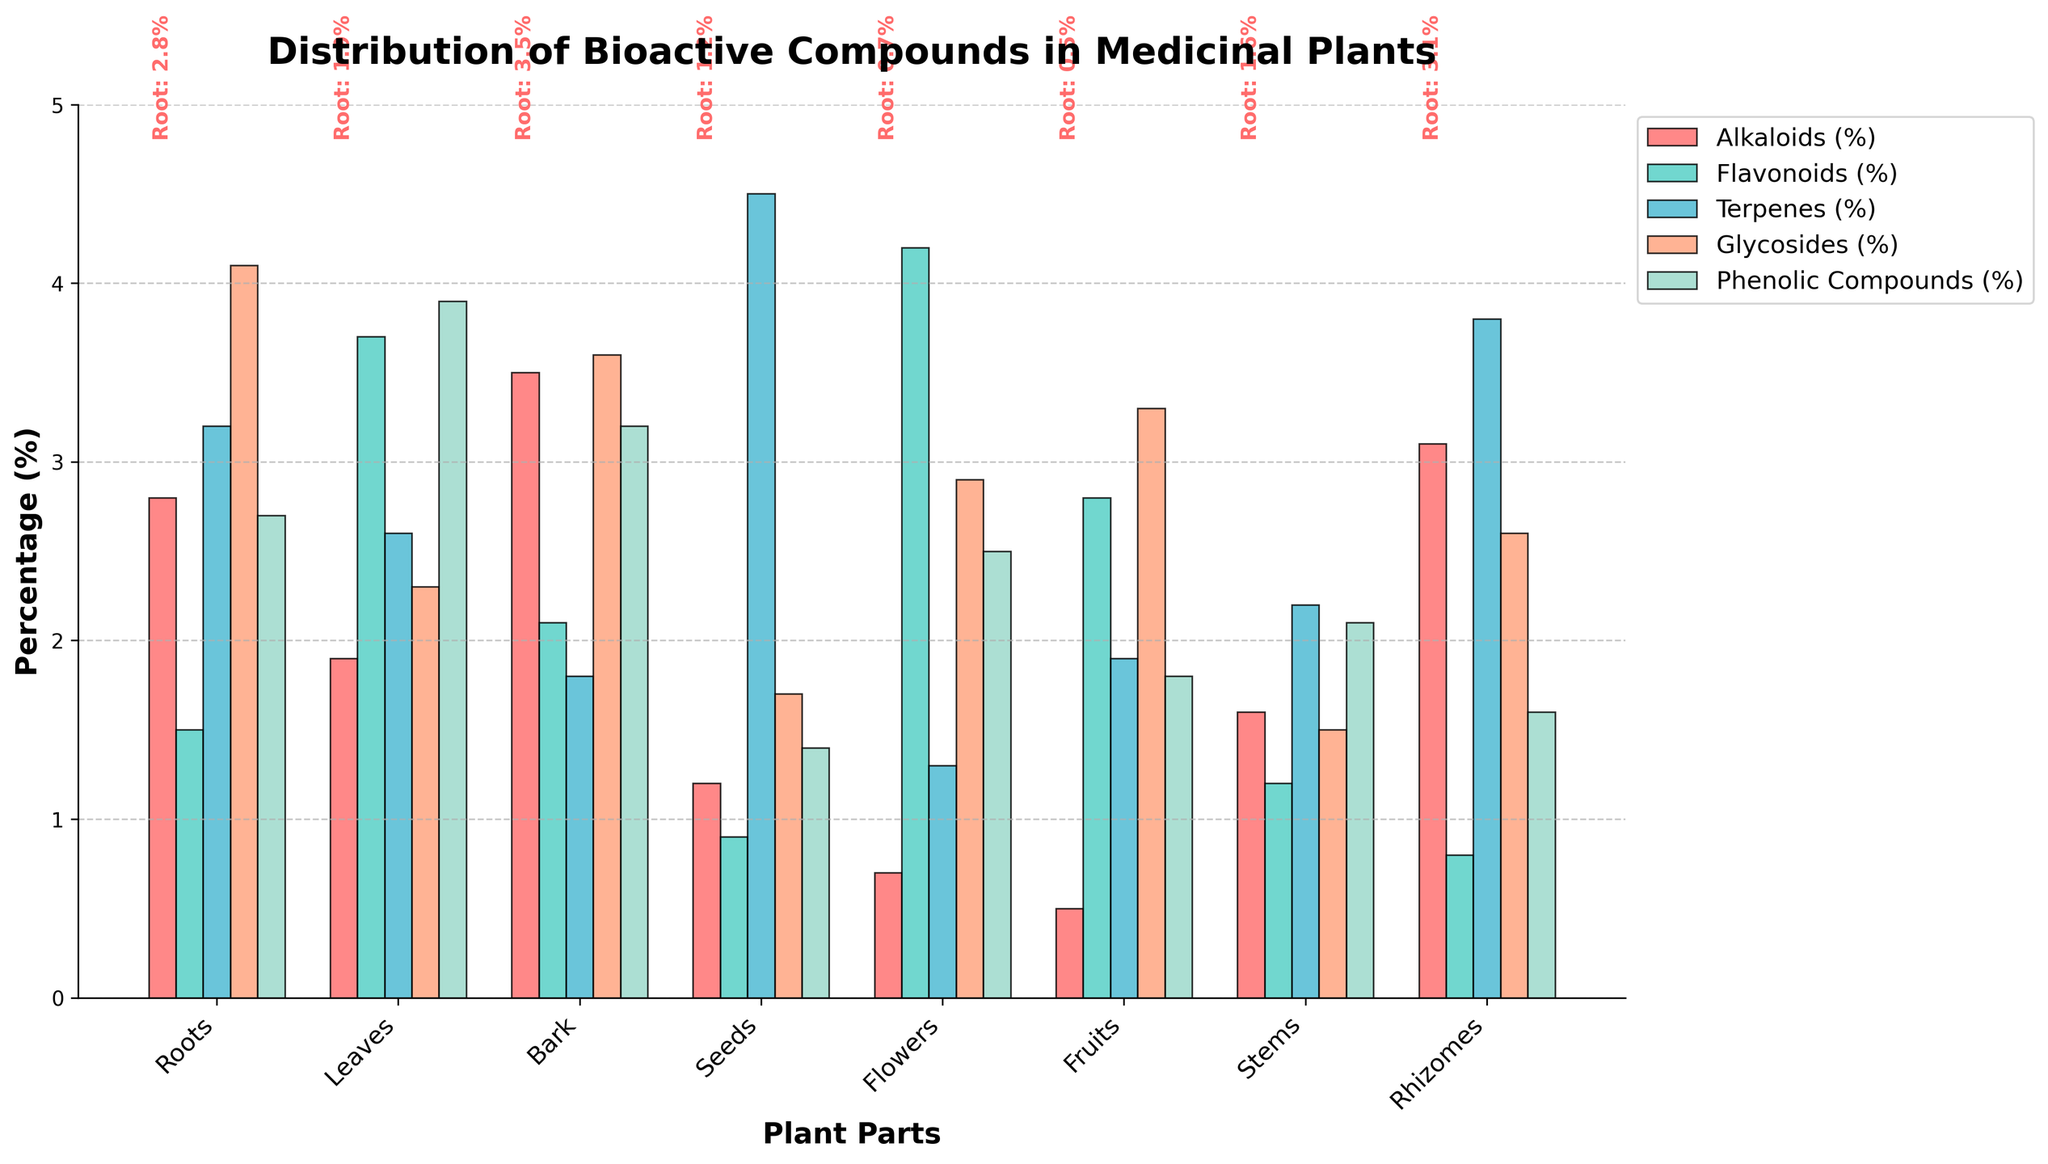Which plant part has the highest percentage of flavonoids? By examining the plot and looking at the bars representing flavonoids (green bars), we can see which plant part has the tallest bar. For flavonoids, the flowers have the highest percentage.
Answer: Flowers Which two bioactive compounds have the closest percentages in leaves? Observing the heights of the bars for each bioactive compound in the leaves, flavonoids and phenolic compounds have comparable bar heights. A closer look reveals that flavonoids are at 3.7% and phenolic compounds at 3.9%, making them the closest in percentage.
Answer: Flavonoids and Phenolic Compounds What is the difference in terpene content between seeds and roots? Referring to the bars corresponding to terpenes (sky blue bars), seeds have a terpene content of 4.5%, and roots have a content of 3.2%. The difference is 4.5% - 3.2% = 1.3%.
Answer: 1.3% Which plant part has the lowest percentage of glycosides? By looking at the bars for glycosides (orange bars), we identify the shortest bar for flowers at 2.9%.
Answer: Flowers What is the sum of the percentages of alkaloids in roots, bark, and rhizomes? Checking the respective alkaloid bars (red bars) for roots, bark, and rhizomes, we find roots at 2.8%, bark at 3.5%, and rhizomes at 3.1%. Therefore, the sum is 2.8% + 3.5% + 3.1% = 9.4%.
Answer: 9.4% Which plant part contains a higher percentage of phenolic compounds than glycosides? By comparing the bar heights of phenolic compounds (light green bars) and glycosides (orange bars) for each plant part, leaves (3.9% phenolic compounds vs. 2.3% glycosides) and stems (2.1% phenolic compounds vs. 1.5% glycosides) meet the criteria.
Answer: Leaves and Stems Are glycosides in leaves greater than, less than, or equal to terpenes in fruits? Consulting the bars for glycosides in leaves and terpenes in fruits, we see 2.3% glycosides in leaves and 1.9% terpenes in fruits. Thus, glycosides in leaves are greater.
Answer: Greater than What is the average percentage of flavonoids across all plant parts? To find the average percentage of flavonoids, sum all flavonoid percentages: 1.5% (roots) + 3.7% (leaves) + 2.1% (bark) + 0.9% (seeds) + 4.2% (flowers) + 2.8% (fruits) + 1.2% (stems) + 0.8% (rhizomes) = 17.2%. Then, divide by the number of plant parts, which is 8. The average is 17.2% / 8 ≈ 2.15%.
Answer: 2.15% 